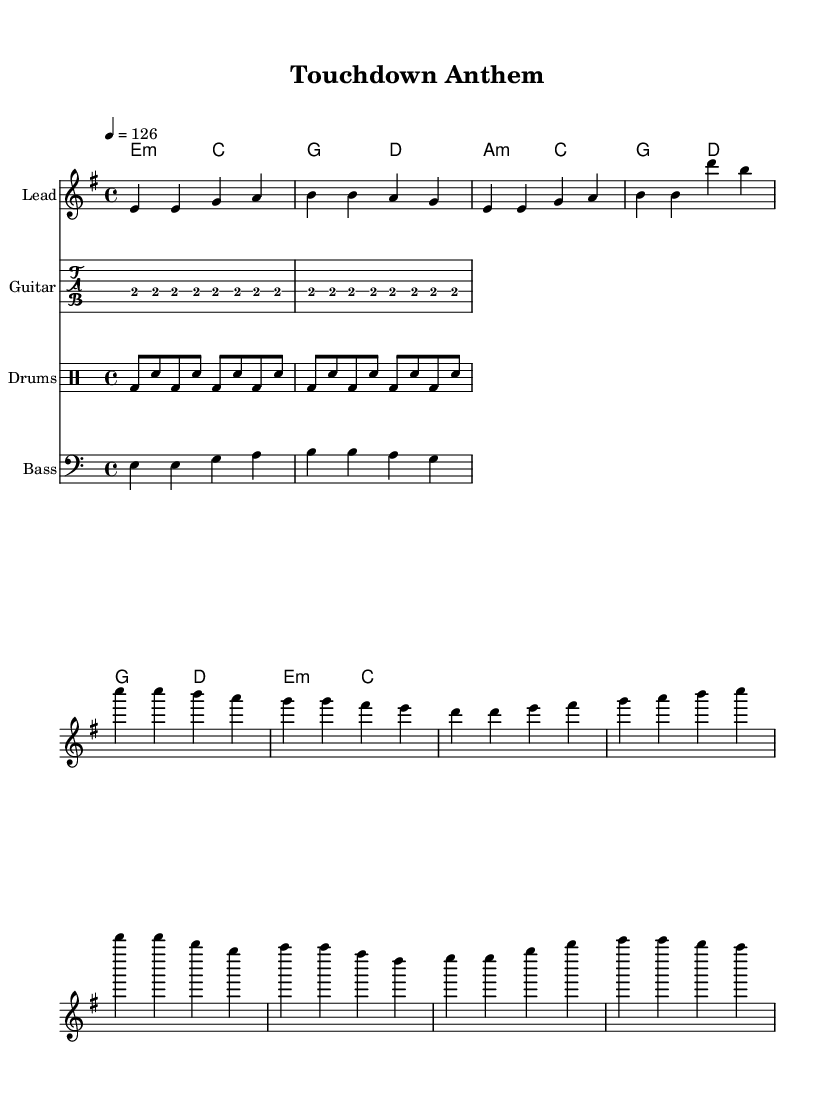What is the key signature of this music? The key signature is indicated right after the clef and specifies that the piece is in E minor, which has one sharp (F#).
Answer: E minor What is the time signature of the piece? The time signature is shown at the beginning of the music, which indicates the number of beats in a measure and the type of note that gets the beat. The piece is in 4/4 time, meaning there are four beats per measure.
Answer: 4/4 What is the tempo of the song? The tempo marking specifies the speed of the music. In this case, it is indicated to be 126 beats per minute, which is a moderate tempo for a rock song.
Answer: 126 What is the main theme of the chorus? The chorus is highlighted in the sheet music with the lyrics "Touchdown! We're scoring high" and "Touchdown! Reaching for the sky," representing the triumphant and energetic essence of a sports victory.
Answer: Touchdown theme How many measures are in the verse section? By counting the measures in the verse part of the melody, we can see there are four measures. Each grouping can be counted from the written music.
Answer: Four Which instrument plays the lead melody? The lead melody is indicated in the staff labeled "Lead," showing that the melody is predominantly played by a lead instrument, likely a guitar or keyboard in a rock arrangement.
Answer: Lead How does the pre-chorus transition to the chorus musically? The pre-chorus ends with a rhythmic buildup, leading into the chorus with a direct shift in intensity and melody, emphasizing the excitement typical of rock music. This reasoning is based on analyzing the melody and harmonic changes between those sections.
Answer: Intensity increase 